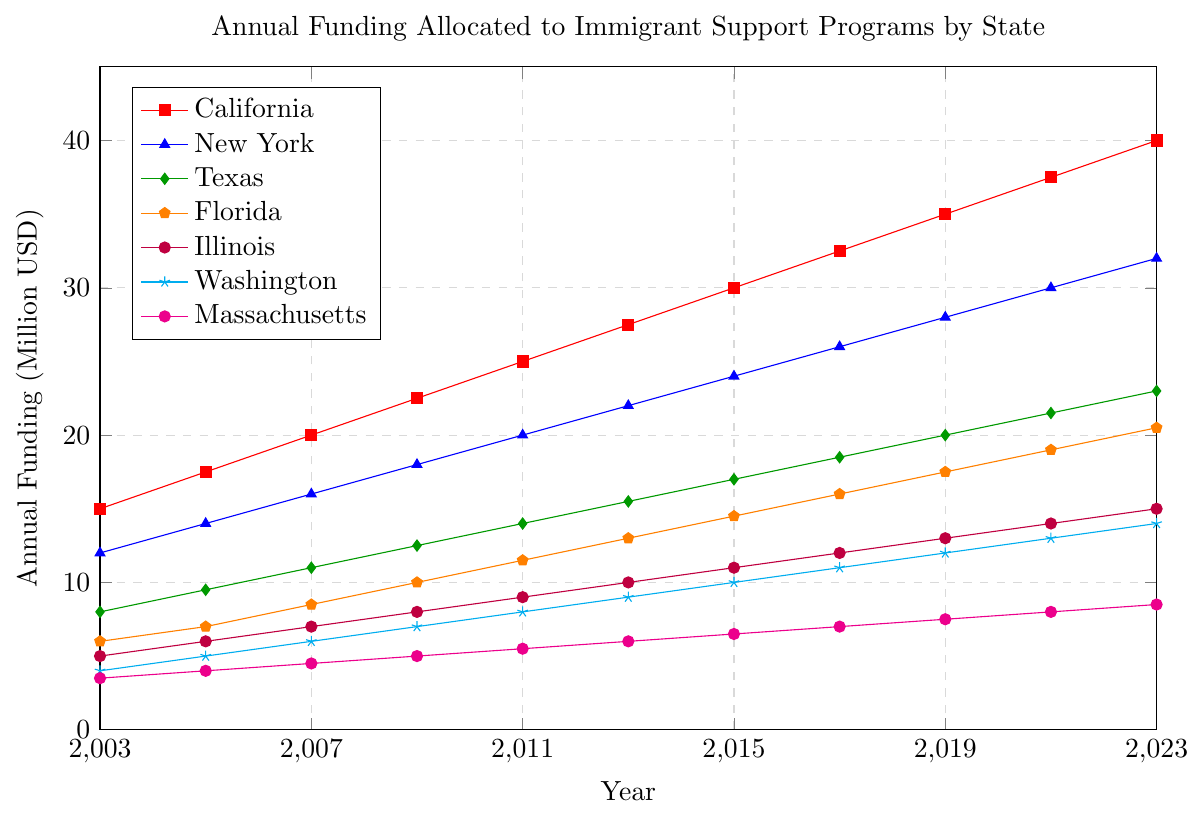Why does California have the highest funding compared to other states? California's funding starts at a higher amount ($15 million) in 2003 and increases consistently over the years, reaching $40 million by 2023. No other state starts or ends at such a high funding level, indicating a continuous prioritization of immigrant support programs in California.
Answer: Higher initial and growth in funding Which state has the steepest increase in annual funding over the 20-year period? California has the steepest increase, starting from $15 million in 2003 to $40 million in 2023. This is a $25 million increase, the greatest among all states shown.
Answer: California Which state allocated the least funding in 2023? By visual comparison of the line endpoints in 2023, Massachusetts allocated the least funding, which is around $8.5 million.
Answer: Massachusetts By how much did the funding for New York increase from 2003 to 2023? The funding for New York in 2003 is $12 million and by 2023 it reaches $32 million. Therefore, the increase is $32 million - $12 million = $20 million.
Answer: $20 million Which years did California's funding surpass $25 million? Referring to the figure, California's funding surpasses $25 million starting from 2011 and continues to increase in successive years until 2023.
Answer: From 2011 onwards How does Texas's funding in 2023 compare to Illinois's funding in 2023? In 2023, Texas's funding is $23 million and Illinois' funding is $15 million, so Texas's funding is higher.
Answer: Texas's funding is higher than Illinois's From 2009 to 2011, which state saw the greatest increase in funding? By looking at the slopes between the 2009 and 2011 data points, California saw the greatest increase, growing from $22.5 million to $25 million, which is a $2.5 million increase.
Answer: California What is the average annual funding for Florida across the 20 years? Summing Florida’s funding over the years: (6 + 7 + 8.5 + 10 + 11.5 + 13 + 14.5 + 16 + 17.5 + 19 + 20.5) = 143; the average is 143 / 11 = 13 million USD.
Answer: 13 million USD Which state had a similar funding amount as Washington in 2023, and how much was it? Massachusetts had similar funding to Washington in 2023, which is around $14 million for Washington and $8.5 million for Massachusetts, hence it's not similar. Illinois has the closest at $15 million; hence no direct match for Washington.
Answer: No direct match for Washington in 2023 What is the difference between the funding allocated by Florida and New York in 2015? Refer to the figure for 2015 values: Florida's funding is $14.5 million while New York's funding is $24 million. The difference is $24 million - $14.5 million = $9.5 million.
Answer: $9.5 million 